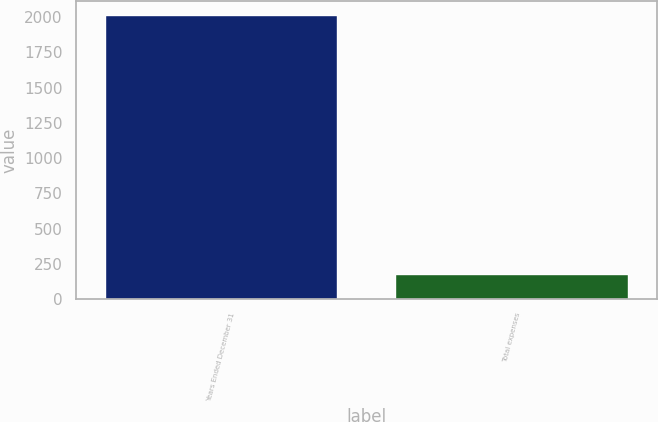<chart> <loc_0><loc_0><loc_500><loc_500><bar_chart><fcel>Years Ended December 31<fcel>Total expenses<nl><fcel>2013<fcel>180<nl></chart> 